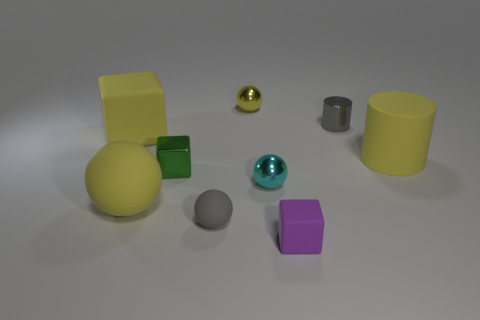Subtract all cylinders. How many objects are left? 7 Subtract 1 green cubes. How many objects are left? 8 Subtract all large cyan metallic cubes. Subtract all purple matte blocks. How many objects are left? 8 Add 4 tiny metal cylinders. How many tiny metal cylinders are left? 5 Add 4 big yellow rubber blocks. How many big yellow rubber blocks exist? 5 